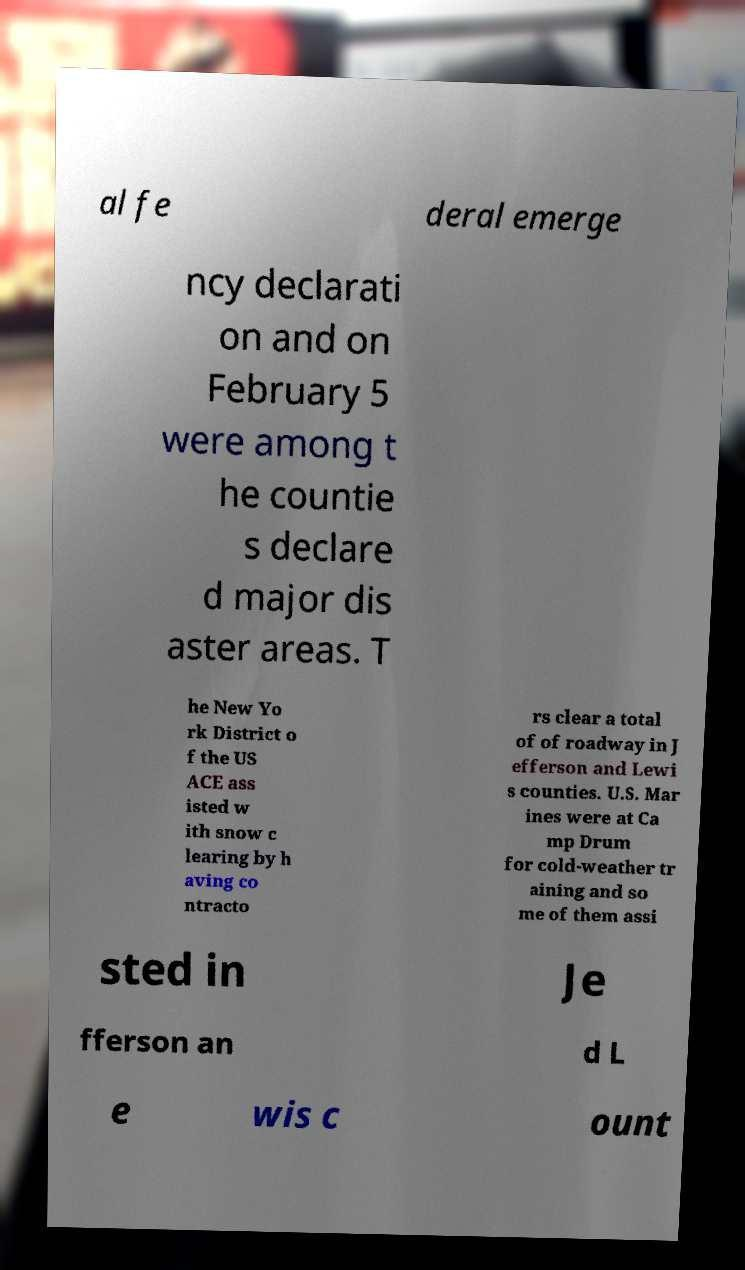Can you accurately transcribe the text from the provided image for me? al fe deral emerge ncy declarati on and on February 5 were among t he countie s declare d major dis aster areas. T he New Yo rk District o f the US ACE ass isted w ith snow c learing by h aving co ntracto rs clear a total of of roadway in J efferson and Lewi s counties. U.S. Mar ines were at Ca mp Drum for cold-weather tr aining and so me of them assi sted in Je fferson an d L e wis c ount 